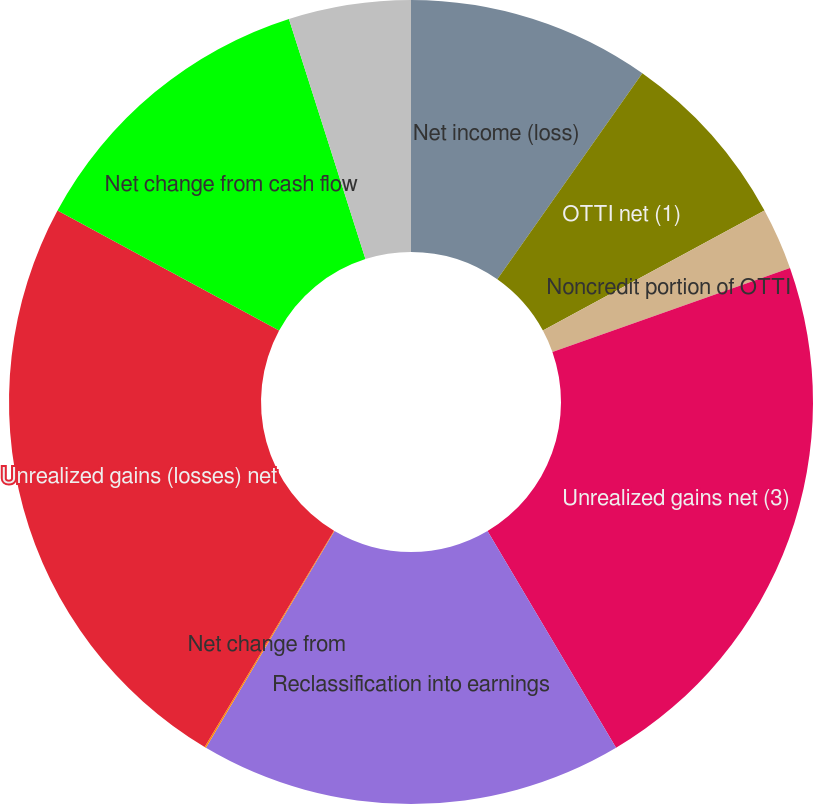<chart> <loc_0><loc_0><loc_500><loc_500><pie_chart><fcel>Net income (loss)<fcel>OTTI net (1)<fcel>Noncredit portion of OTTI<fcel>Unrealized gains net (3)<fcel>Reclassification into earnings<fcel>Net change from<fcel>Unrealized gains (losses) net<fcel>Net change from cash flow<fcel>Foreign currency translation<nl><fcel>9.76%<fcel>7.34%<fcel>2.49%<fcel>21.89%<fcel>17.04%<fcel>0.06%<fcel>24.32%<fcel>12.19%<fcel>4.91%<nl></chart> 